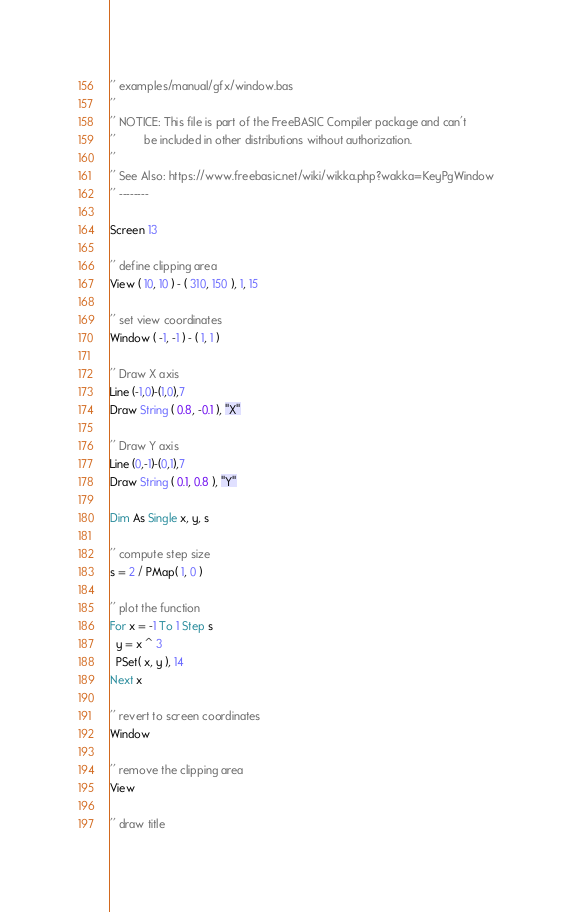Convert code to text. <code><loc_0><loc_0><loc_500><loc_500><_VisualBasic_>'' examples/manual/gfx/window.bas
''
'' NOTICE: This file is part of the FreeBASIC Compiler package and can't
''         be included in other distributions without authorization.
''
'' See Also: https://www.freebasic.net/wiki/wikka.php?wakka=KeyPgWindow
'' --------

Screen 13

'' define clipping area
View ( 10, 10 ) - ( 310, 150 ), 1, 15    

'' set view coordinates
Window ( -1, -1 ) - ( 1, 1 )             

'' Draw X axis
Line (-1,0)-(1,0),7
Draw String ( 0.8, -0.1 ), "X"

'' Draw Y axis
Line (0,-1)-(0,1),7
Draw String ( 0.1, 0.8 ), "Y"

Dim As Single x, y, s

'' compute step size
s = 2 / PMap( 1, 0 )

'' plot the function
For x = -1 To 1 Step s
  y = x ^ 3
  PSet( x, y ), 14
Next x

'' revert to screen coordinates
Window

'' remove the clipping area
View

'' draw title</code> 